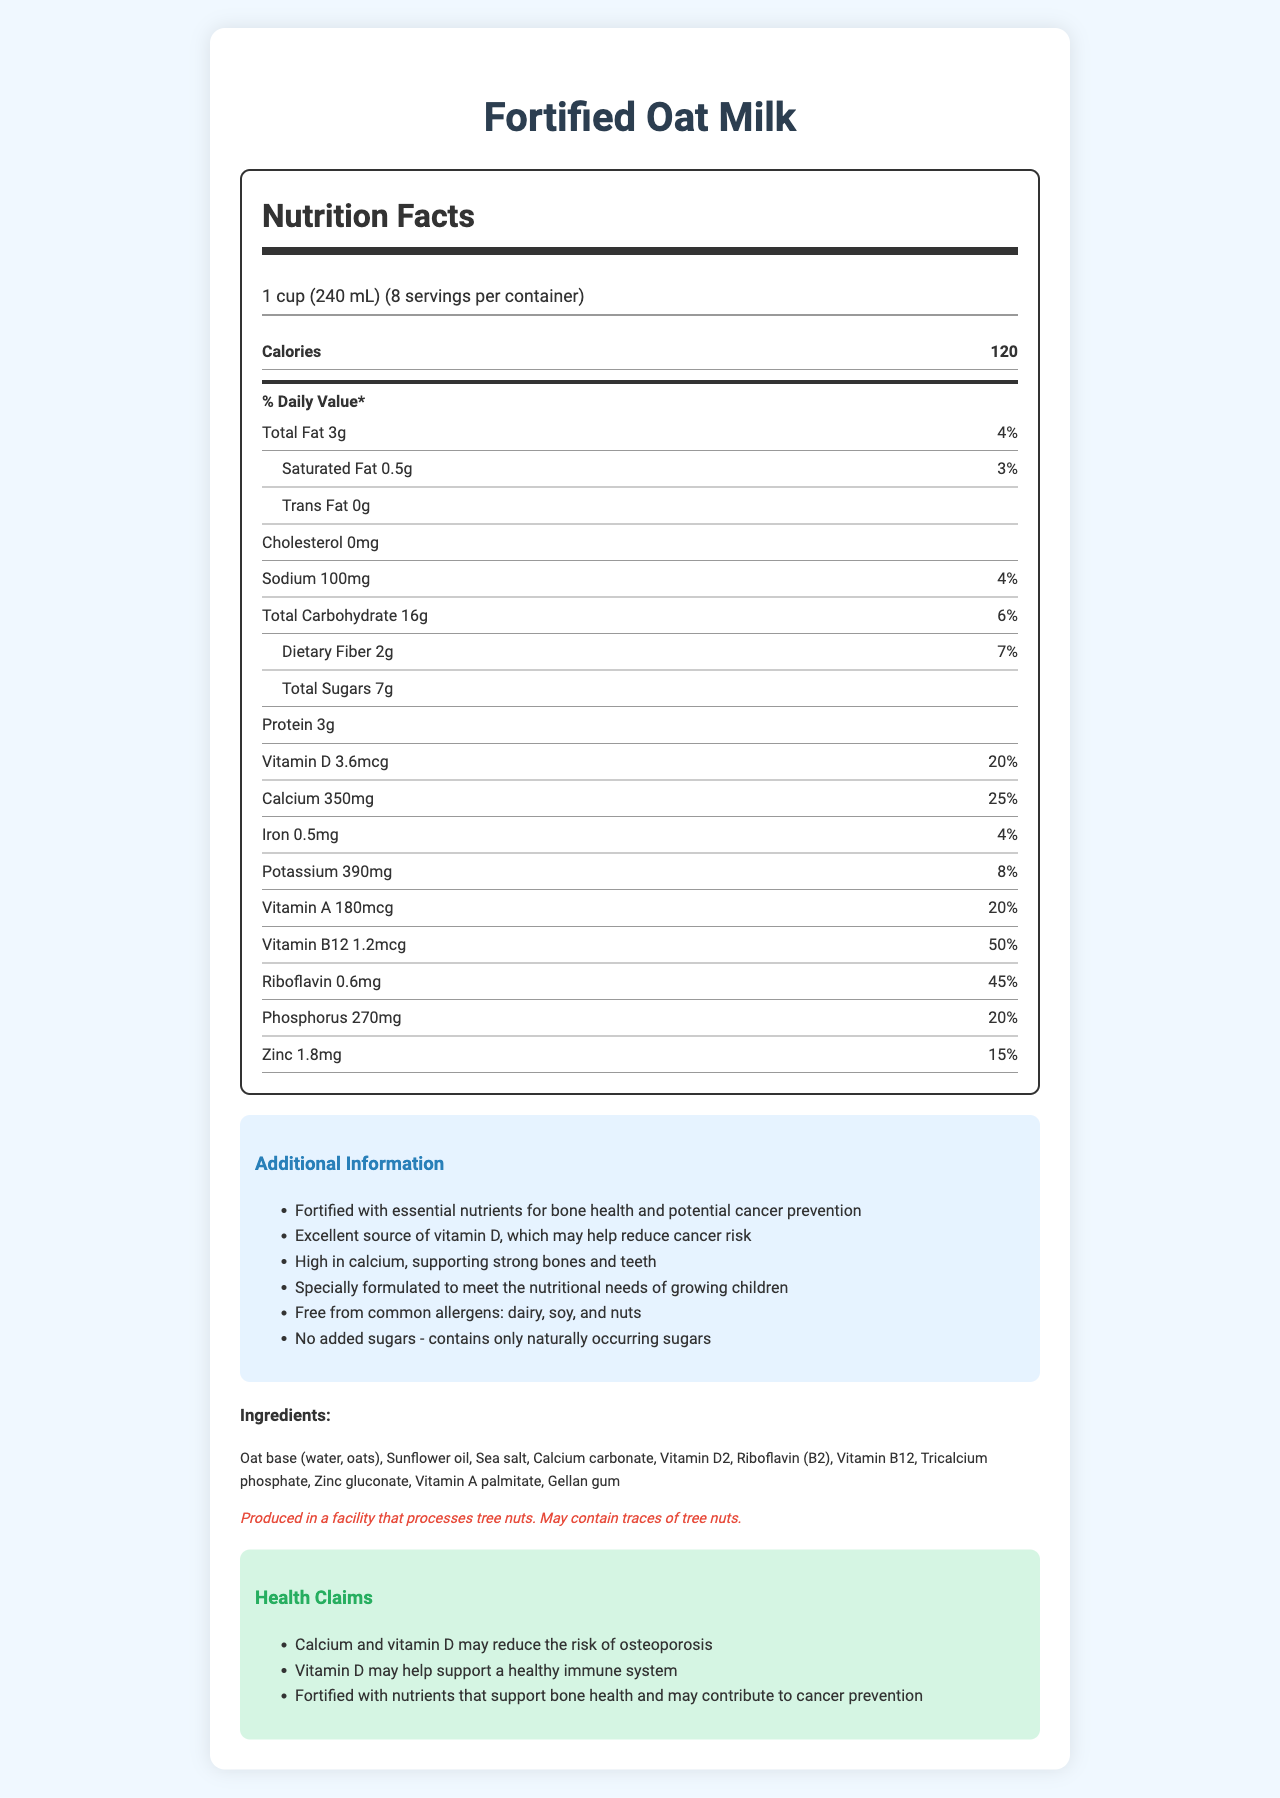what is the serving size for Fortified Oat Milk? The serving size is specified at the beginning of the nutrition facts label.
Answer: 1 cup (240 mL) how many servings are in one container? The document states "8 servings per container" just below the serving size information.
Answer: 8 what percentage of the daily value of vitamin D is provided per serving? The nutrition facts label indicates that one serving provides 20% of the daily value for vitamin D.
Answer: 20% how much calcium is in one serving? The label lists the amount of calcium per serving as 350mg.
Answer: 350mg is there any added sugar in this product? The additional information section mentions that it "contains only naturally occurring sugars".
Answer: No what is the total number of calories per serving? The calorie content per serving is listed as 120.
Answer: 120 which nutrient is provided at the highest daily value percentage per serving? A. Vitamin D B. Calcium C. Riboflavin D. Vitamin B12 The daily value for vitamin B12 is 50%, which is higher than the percentages for vitamin D (20%), calcium (25%), and riboflavin (45%).
Answer: D. Vitamin B12 which nutrient does not have a specified daily value on the label? A. Total Fat B. Sodium C. Trans Fat D. Protein The document indicates that the daily value for trans fat is not listed.
Answer: C. Trans Fat is the product free from common allergens like dairy, soy, and nuts? The additional information section states that the product is "free from common allergens: dairy, soy, and nuts."
Answer: Yes does the product contain cholesterol? The label lists the cholesterol content as "0mg", indicating it does not contain cholesterol.
Answer: No summarize the main insights from the document in relation to bone health and cancer prevention. The document highlights that the fortified oat milk is beneficial for bone health due to its high calcium and vitamin D content. It also promotes potential cancer prevention benefits of vitamin D. The additional information and health claims sections reinforce these points.
Answer: The Fortified Oat Milk provides essential nutrients for bone health, including 350mg of calcium (25% daily value) and 3.6mcg of vitamin D (20% daily value). It emphasizes being an excellent source of vitamin D, which may help reduce cancer risk, as mentioned in the additional information and health claims sections. The product is free from common allergens like dairy, soy, and nuts. can the level of vitamin D in this product definitively prevent cancer in my child? The nutrition facts label and health claims section suggest vitamin D may help reduce cancer risk, but they do not provide definitive evidence or guarantees for cancer prevention.
Answer: Not enough information are naturally-occurring sugars indicated on the nutrition label? A. Yes B. No C. Not Specified The additional information section states "No added sugars - contains only naturally occurring sugars."
Answer: A. Yes 